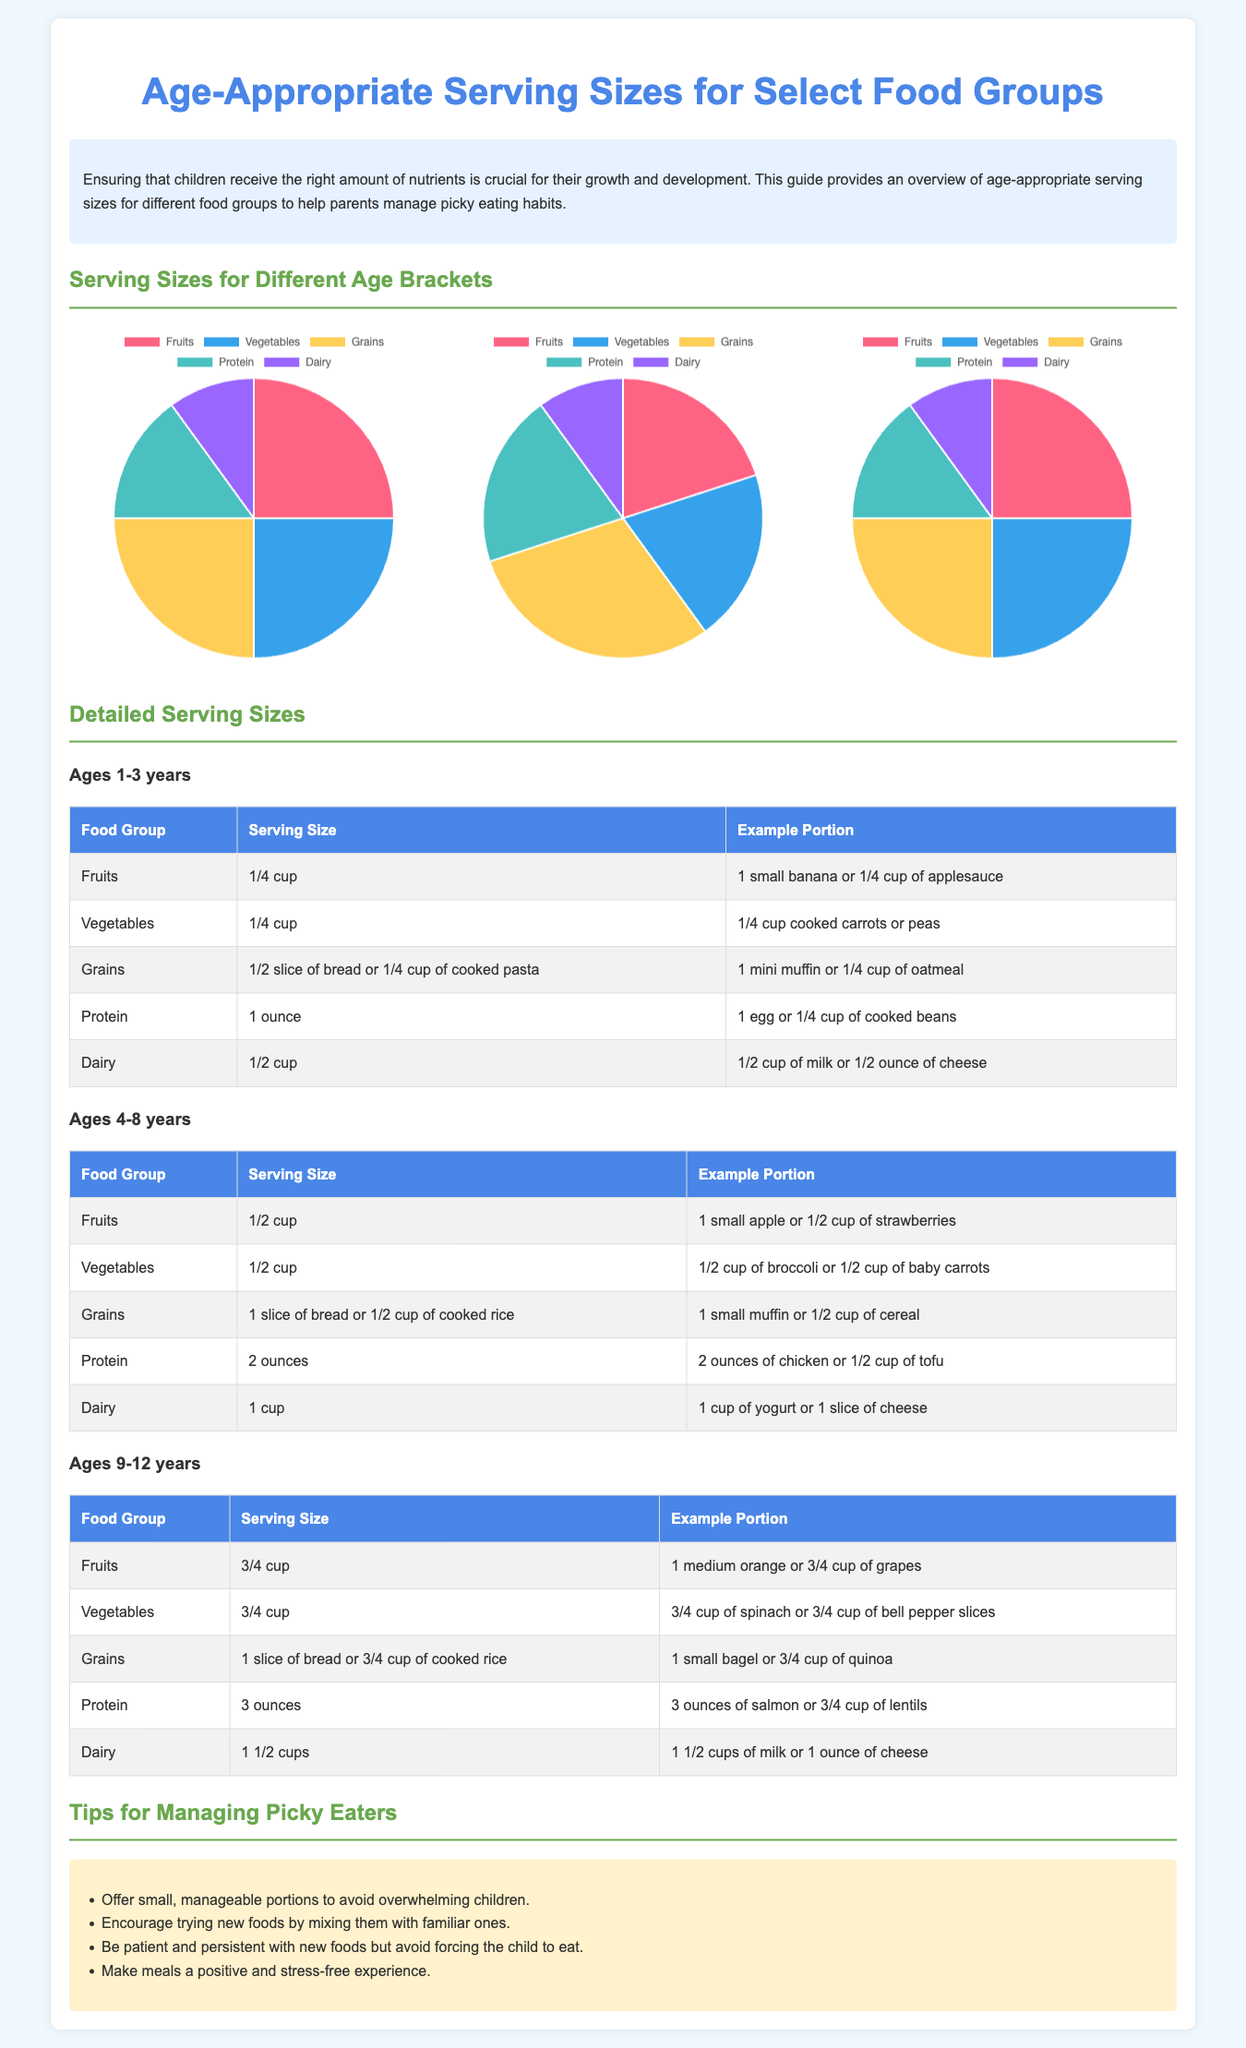What is the serving size of fruits for ages 1-3 years? The serving size of fruits for ages 1-3 years is listed in the table, which indicates 1/4 cup.
Answer: 1/4 cup What is the serving size of dairy for ages 4-8 years? The serving size of dairy for ages 4-8 years can be found in the respective table, and it is 1 cup.
Answer: 1 cup How many ounces of protein are recommended for ages 9-12 years? The document specifies in the table that the serving size for protein for ages 9-12 years is 3 ounces.
Answer: 3 ounces Which food group has the largest percentage allocation for ages 4-8 years? The pie chart for ages 4-8 years indicates that grains have the largest percentage allocation at 30.
Answer: Grains What is the recommended serving size for vegetables for ages 1-3 years? The serving size for vegetables for ages 1-3 years is detailed in the table as 1/4 cup.
Answer: 1/4 cup How does the serving size of protein for ages 4-8 years compare to that for ages 1-3 years? The serving size for protein for ages 4-8 years is 2 ounces, while for ages 1-3 years, it is 1 ounce, indicating an increase.
Answer: Increase What color represents fruits in the pie charts? The color representing fruits in the pie charts is visible in the chart legend and is represented by pink.
Answer: Pink What is a tip provided for managing picky eaters? The tips section lists several strategies, one of which is to offer small, manageable portions to avoid overwhelming children.
Answer: Offer small portions 